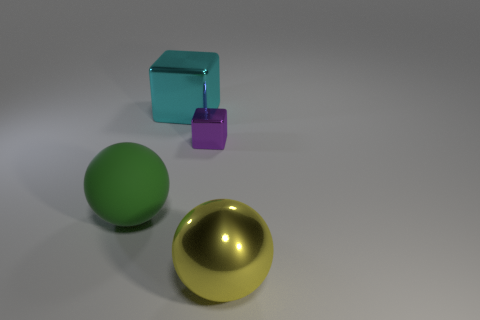Add 2 big balls. How many objects exist? 6 Subtract 0 brown cylinders. How many objects are left? 4 Subtract all big cyan cubes. Subtract all metallic balls. How many objects are left? 2 Add 3 large metallic objects. How many large metallic objects are left? 5 Add 4 big yellow metallic balls. How many big yellow metallic balls exist? 5 